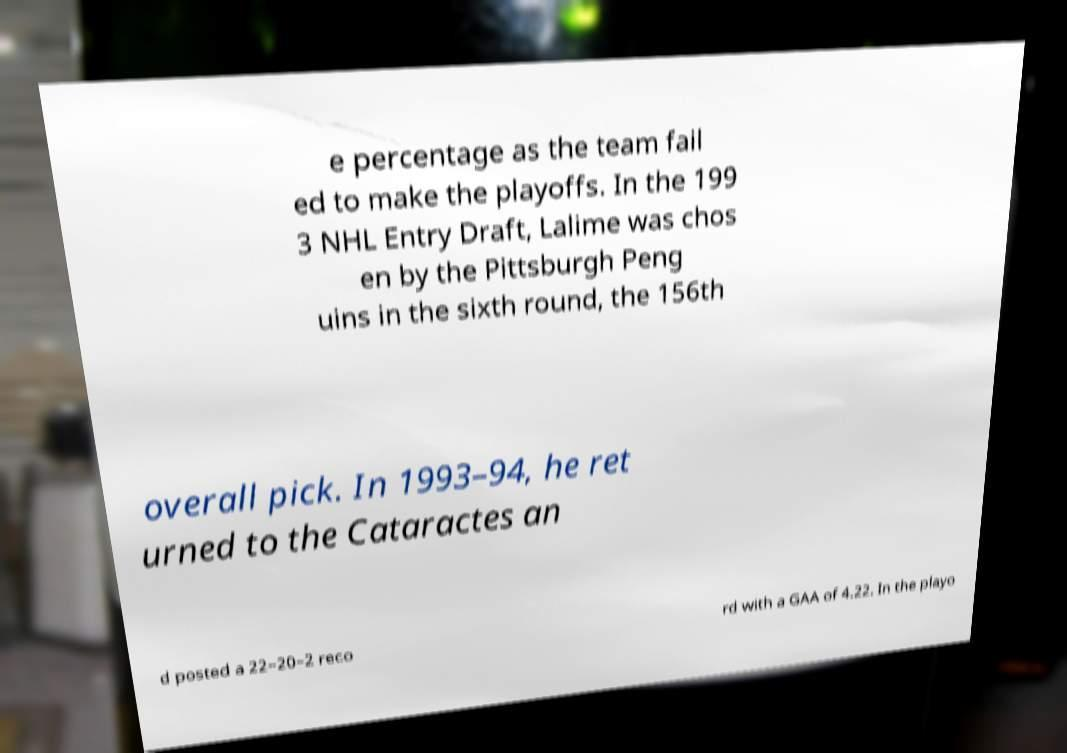What messages or text are displayed in this image? I need them in a readable, typed format. e percentage as the team fail ed to make the playoffs. In the 199 3 NHL Entry Draft, Lalime was chos en by the Pittsburgh Peng uins in the sixth round, the 156th overall pick. In 1993–94, he ret urned to the Cataractes an d posted a 22–20–2 reco rd with a GAA of 4.22. In the playo 